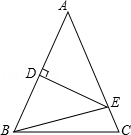Looking closely at the geometric relationships shown, can you explain why triangle ADE might be isosceles? Triangle ADE is likely isosceles because AD is given as 50 units and D is the midpoint of AB, suggesting AE would also be 50 units as it represents half of AB given AB=AC with AC also bisected by DE at E. Therefore, with AD = DE = 50 units and our assumption for AE, it forms two equal sides of the triangle, hence making ADE isosceles. 